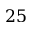<formula> <loc_0><loc_0><loc_500><loc_500>2 5</formula> 